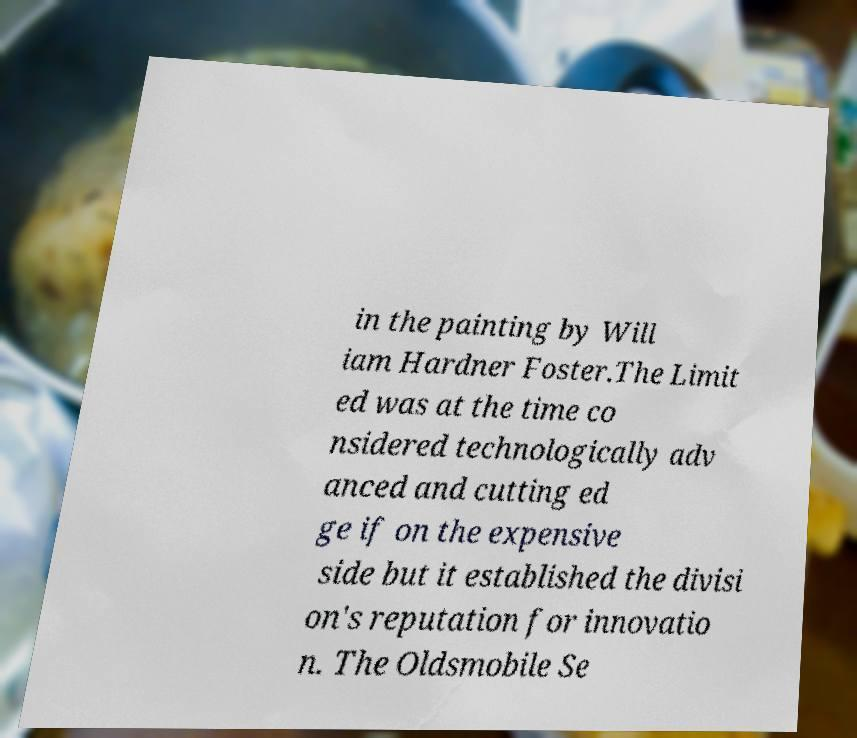I need the written content from this picture converted into text. Can you do that? in the painting by Will iam Hardner Foster.The Limit ed was at the time co nsidered technologically adv anced and cutting ed ge if on the expensive side but it established the divisi on's reputation for innovatio n. The Oldsmobile Se 